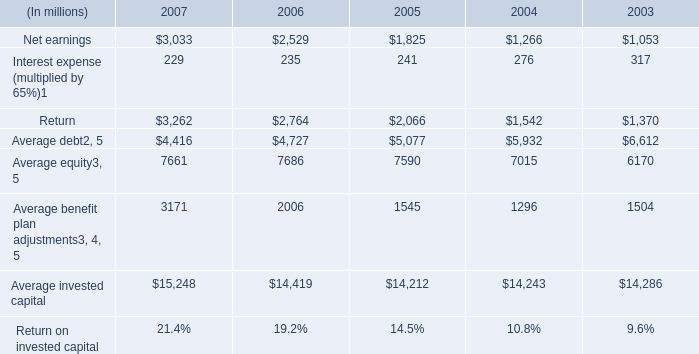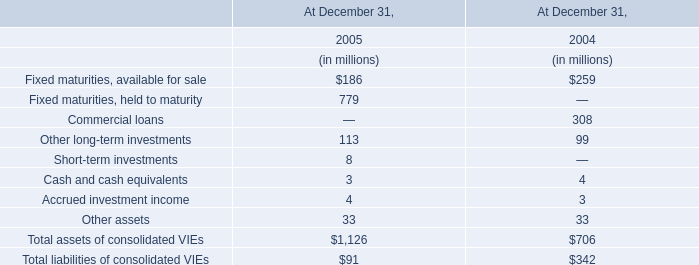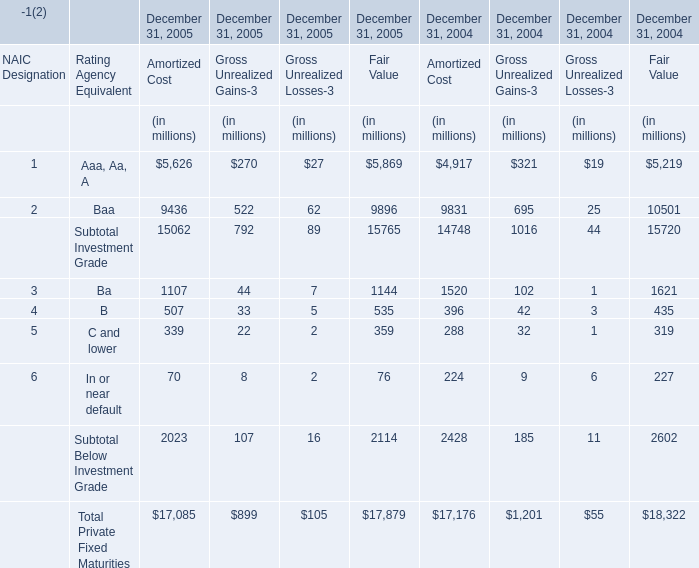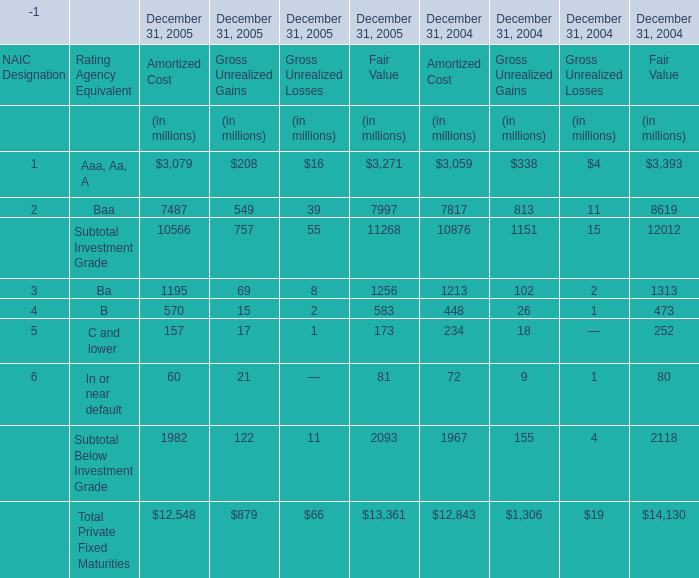What's the current increasing rate of Aaa, Aa, A for Amortized Cost? 
Computations: ((3079 - 3059) / 3059)
Answer: 0.00654. 